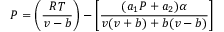Convert formula to latex. <formula><loc_0><loc_0><loc_500><loc_500>P = \left ( { \frac { R T } { v - b } } \right ) - \left [ { \frac { ( a _ { 1 } P + a _ { 2 } ) \alpha } { v ( v + b ) + b ( v - b ) } } \right ]</formula> 